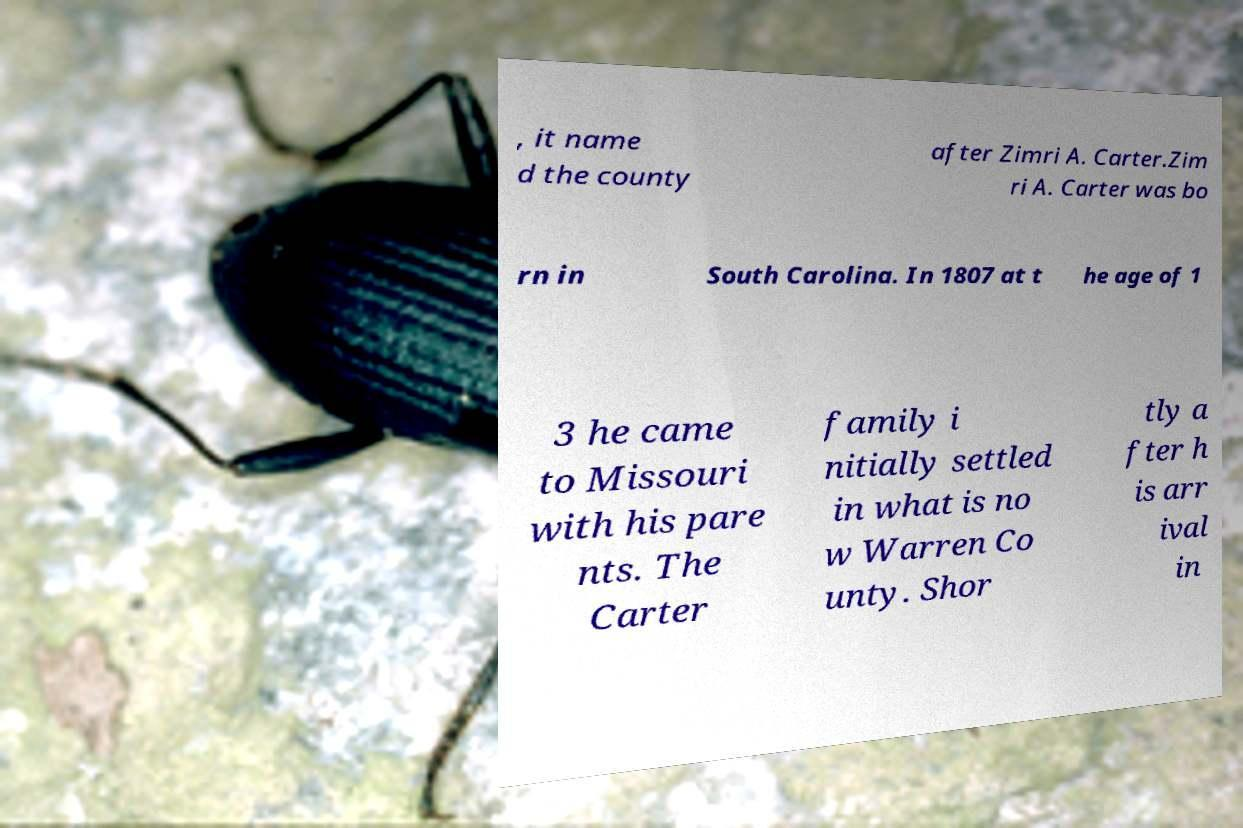There's text embedded in this image that I need extracted. Can you transcribe it verbatim? , it name d the county after Zimri A. Carter.Zim ri A. Carter was bo rn in South Carolina. In 1807 at t he age of 1 3 he came to Missouri with his pare nts. The Carter family i nitially settled in what is no w Warren Co unty. Shor tly a fter h is arr ival in 